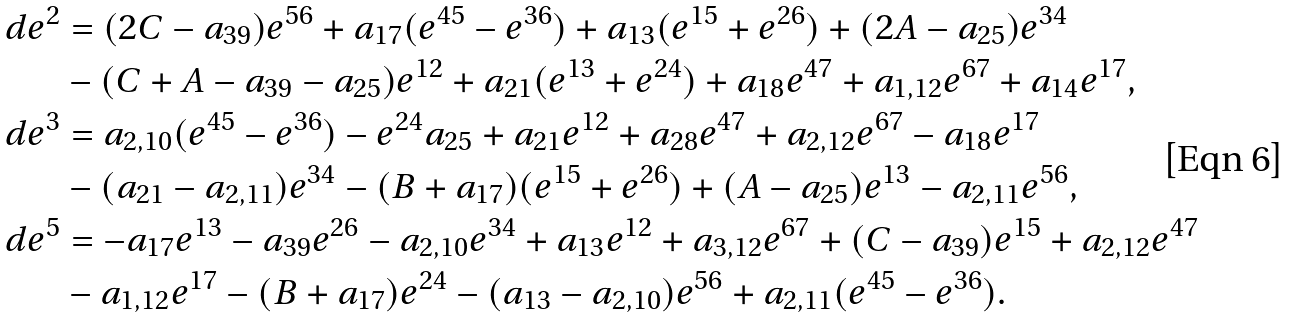<formula> <loc_0><loc_0><loc_500><loc_500>d e ^ { 2 } & = { ( 2 C - a _ { 3 9 } ) } e ^ { 5 6 } + a _ { 1 7 } ( e ^ { 4 5 } - e ^ { 3 6 } ) + a _ { 1 3 } ( e ^ { 1 5 } + e ^ { 2 6 } ) + { ( 2 A - a _ { 2 5 } ) } e ^ { 3 4 } \\ & - { ( C + A - a _ { 3 9 } - a _ { 2 5 } ) } e ^ { 1 2 } + a _ { 2 1 } ( e ^ { 1 3 } + e ^ { 2 4 } ) + a _ { 1 8 } e ^ { 4 7 } + a _ { 1 , 1 2 } e ^ { 6 7 } + a _ { 1 4 } e ^ { 1 7 } , \\ d e ^ { 3 } & = a _ { 2 , 1 0 } ( e ^ { 4 5 } - e ^ { 3 6 } ) - e ^ { 2 4 } a _ { 2 5 } + a _ { 2 1 } e ^ { 1 2 } + a _ { 2 8 } e ^ { 4 7 } + a _ { 2 , 1 2 } e ^ { 6 7 } - a _ { 1 8 } e ^ { 1 7 } \\ & - { ( a _ { 2 1 } - a _ { 2 , 1 1 } ) } e ^ { 3 4 } - { ( B + a _ { 1 7 } ) } ( e ^ { 1 5 } + e ^ { 2 6 } ) + { ( A - a _ { 2 5 } ) } e ^ { 1 3 } - a _ { 2 , 1 1 } e ^ { 5 6 } , \\ d e ^ { 5 } & = - a _ { 1 7 } e ^ { 1 3 } - a _ { 3 9 } e ^ { 2 6 } - a _ { 2 , 1 0 } e ^ { 3 4 } + a _ { 1 3 } e ^ { 1 2 } + a _ { 3 , 1 2 } e ^ { 6 7 } + { ( C - a _ { 3 9 } ) } e ^ { 1 5 } + a _ { 2 , 1 2 } e ^ { 4 7 } \\ & - a _ { 1 , 1 2 } e ^ { 1 7 } - { ( B + a _ { 1 7 } ) } e ^ { 2 4 } - { ( a _ { 1 3 } - a _ { 2 , 1 0 } ) } e ^ { 5 6 } + a _ { 2 , 1 1 } ( e ^ { 4 5 } - e ^ { 3 6 } ) .</formula> 